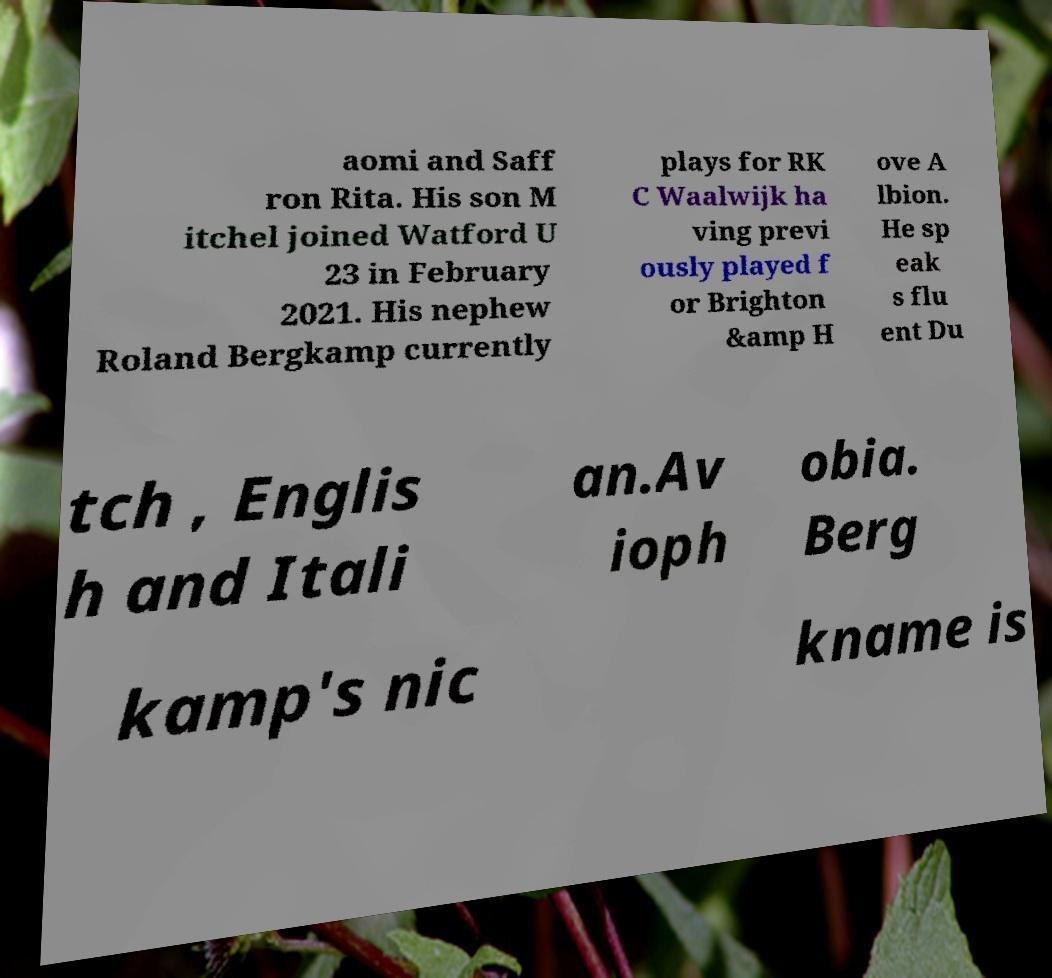Could you extract and type out the text from this image? aomi and Saff ron Rita. His son M itchel joined Watford U 23 in February 2021. His nephew Roland Bergkamp currently plays for RK C Waalwijk ha ving previ ously played f or Brighton &amp H ove A lbion. He sp eak s flu ent Du tch , Englis h and Itali an.Av ioph obia. Berg kamp's nic kname is 